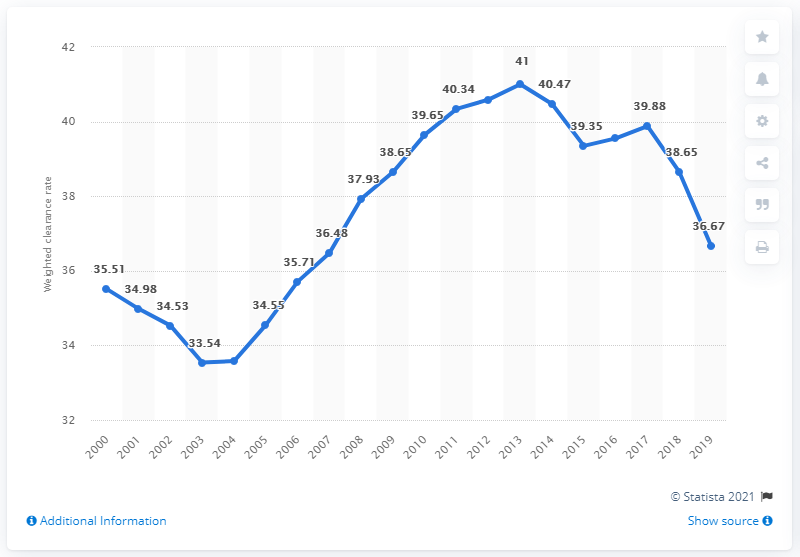List a handful of essential elements in this visual. In 2000, Canada's clearance rate, which is a measure of the proportion of reported crimes that are solved, was 35.51%. In 2019, the weighted clearance rate in Canada was 36.67. 